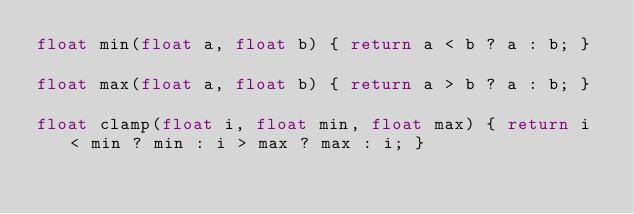Convert code to text. <code><loc_0><loc_0><loc_500><loc_500><_C_>float min(float a, float b) { return a < b ? a : b; }

float max(float a, float b) { return a > b ? a : b; }

float clamp(float i, float min, float max) { return i < min ? min : i > max ? max : i; }
</code> 